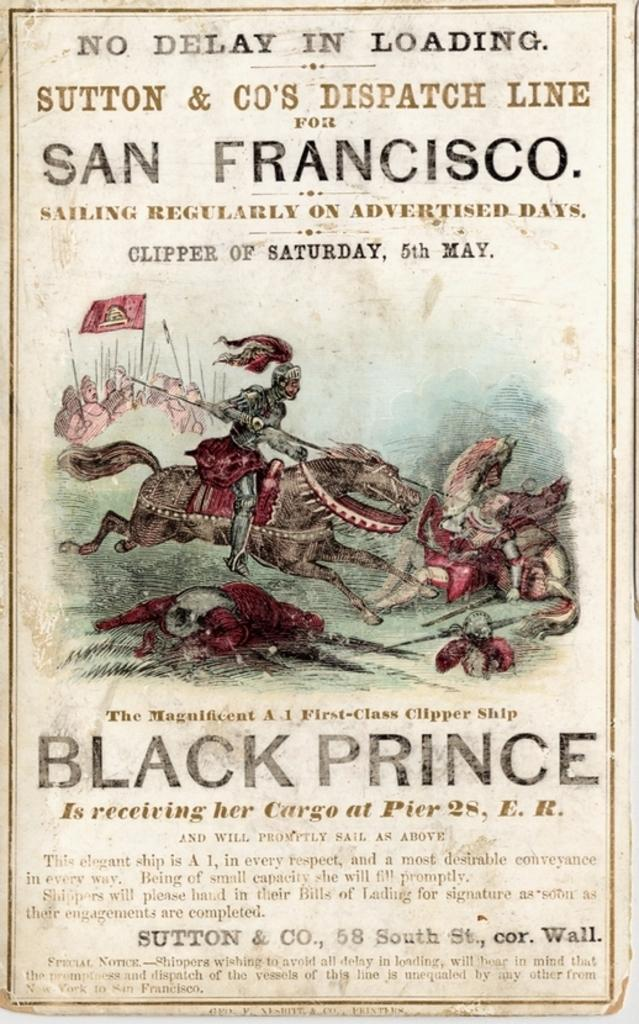Provide a one-sentence caption for the provided image. An old advertisement for the Black Prince clipper ship in San Francisco. 